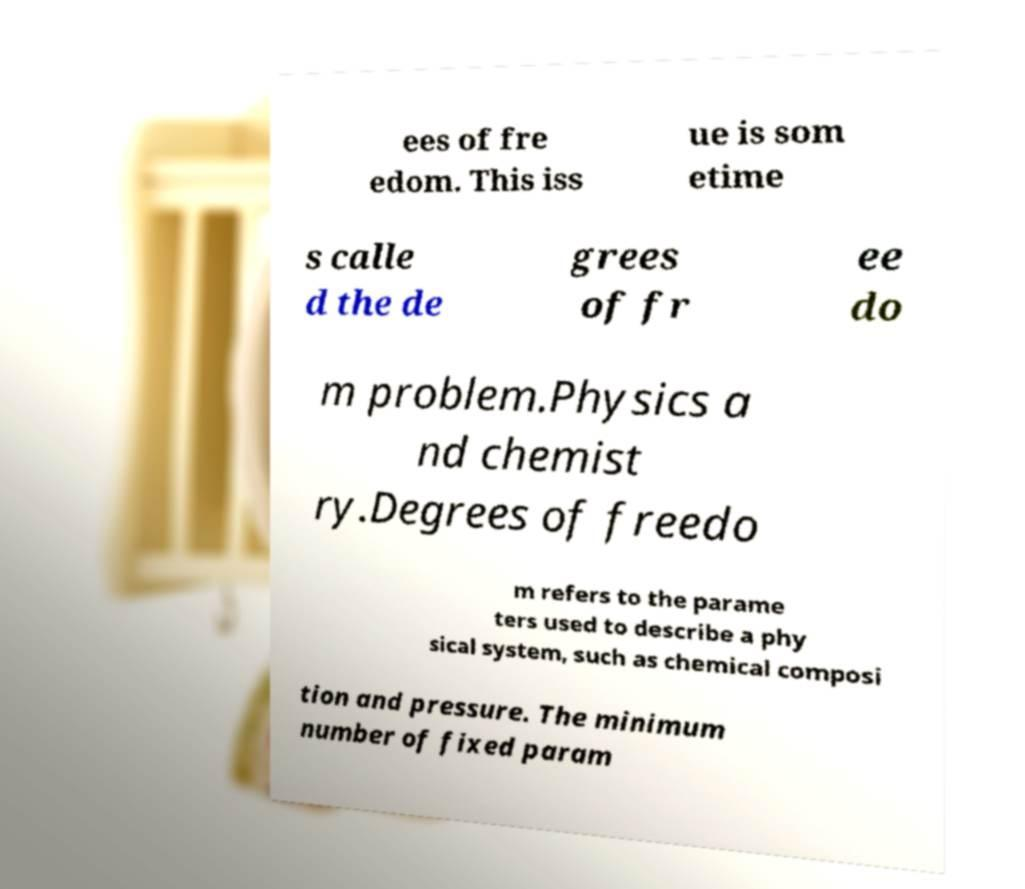Can you read and provide the text displayed in the image?This photo seems to have some interesting text. Can you extract and type it out for me? ees of fre edom. This iss ue is som etime s calle d the de grees of fr ee do m problem.Physics a nd chemist ry.Degrees of freedo m refers to the parame ters used to describe a phy sical system, such as chemical composi tion and pressure. The minimum number of fixed param 